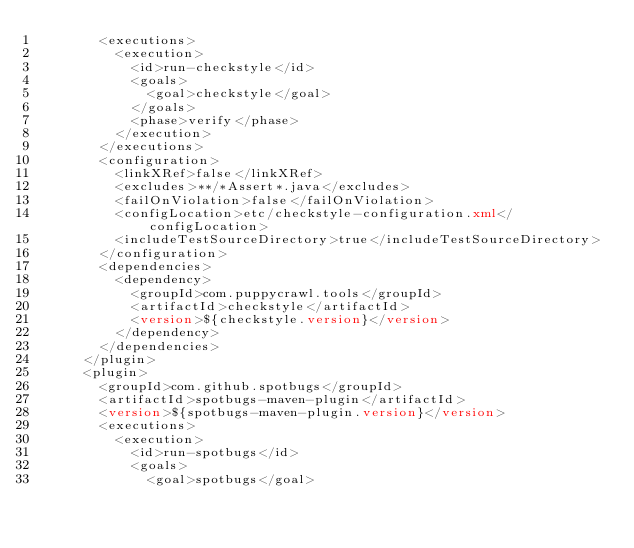<code> <loc_0><loc_0><loc_500><loc_500><_XML_>        <executions>
          <execution>
            <id>run-checkstyle</id>
            <goals>
              <goal>checkstyle</goal>
            </goals>
            <phase>verify</phase>
          </execution>
        </executions>
        <configuration>
          <linkXRef>false</linkXRef>
          <excludes>**/*Assert*.java</excludes>
          <failOnViolation>false</failOnViolation>
          <configLocation>etc/checkstyle-configuration.xml</configLocation>
          <includeTestSourceDirectory>true</includeTestSourceDirectory>
        </configuration>
        <dependencies>
          <dependency>
            <groupId>com.puppycrawl.tools</groupId>
            <artifactId>checkstyle</artifactId>
            <version>${checkstyle.version}</version>
          </dependency>
        </dependencies>
      </plugin>
      <plugin>
        <groupId>com.github.spotbugs</groupId>
        <artifactId>spotbugs-maven-plugin</artifactId>
        <version>${spotbugs-maven-plugin.version}</version>
        <executions>
          <execution>
            <id>run-spotbugs</id>
            <goals>
              <goal>spotbugs</goal></code> 